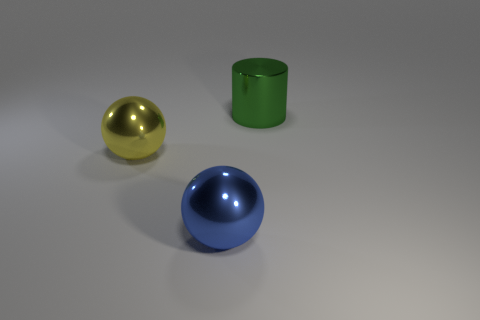Add 3 metal cylinders. How many objects exist? 6 Subtract all cylinders. How many objects are left? 2 Subtract 0 red balls. How many objects are left? 3 Subtract all yellow metal balls. Subtract all large blue spheres. How many objects are left? 1 Add 2 green cylinders. How many green cylinders are left? 3 Add 2 purple objects. How many purple objects exist? 2 